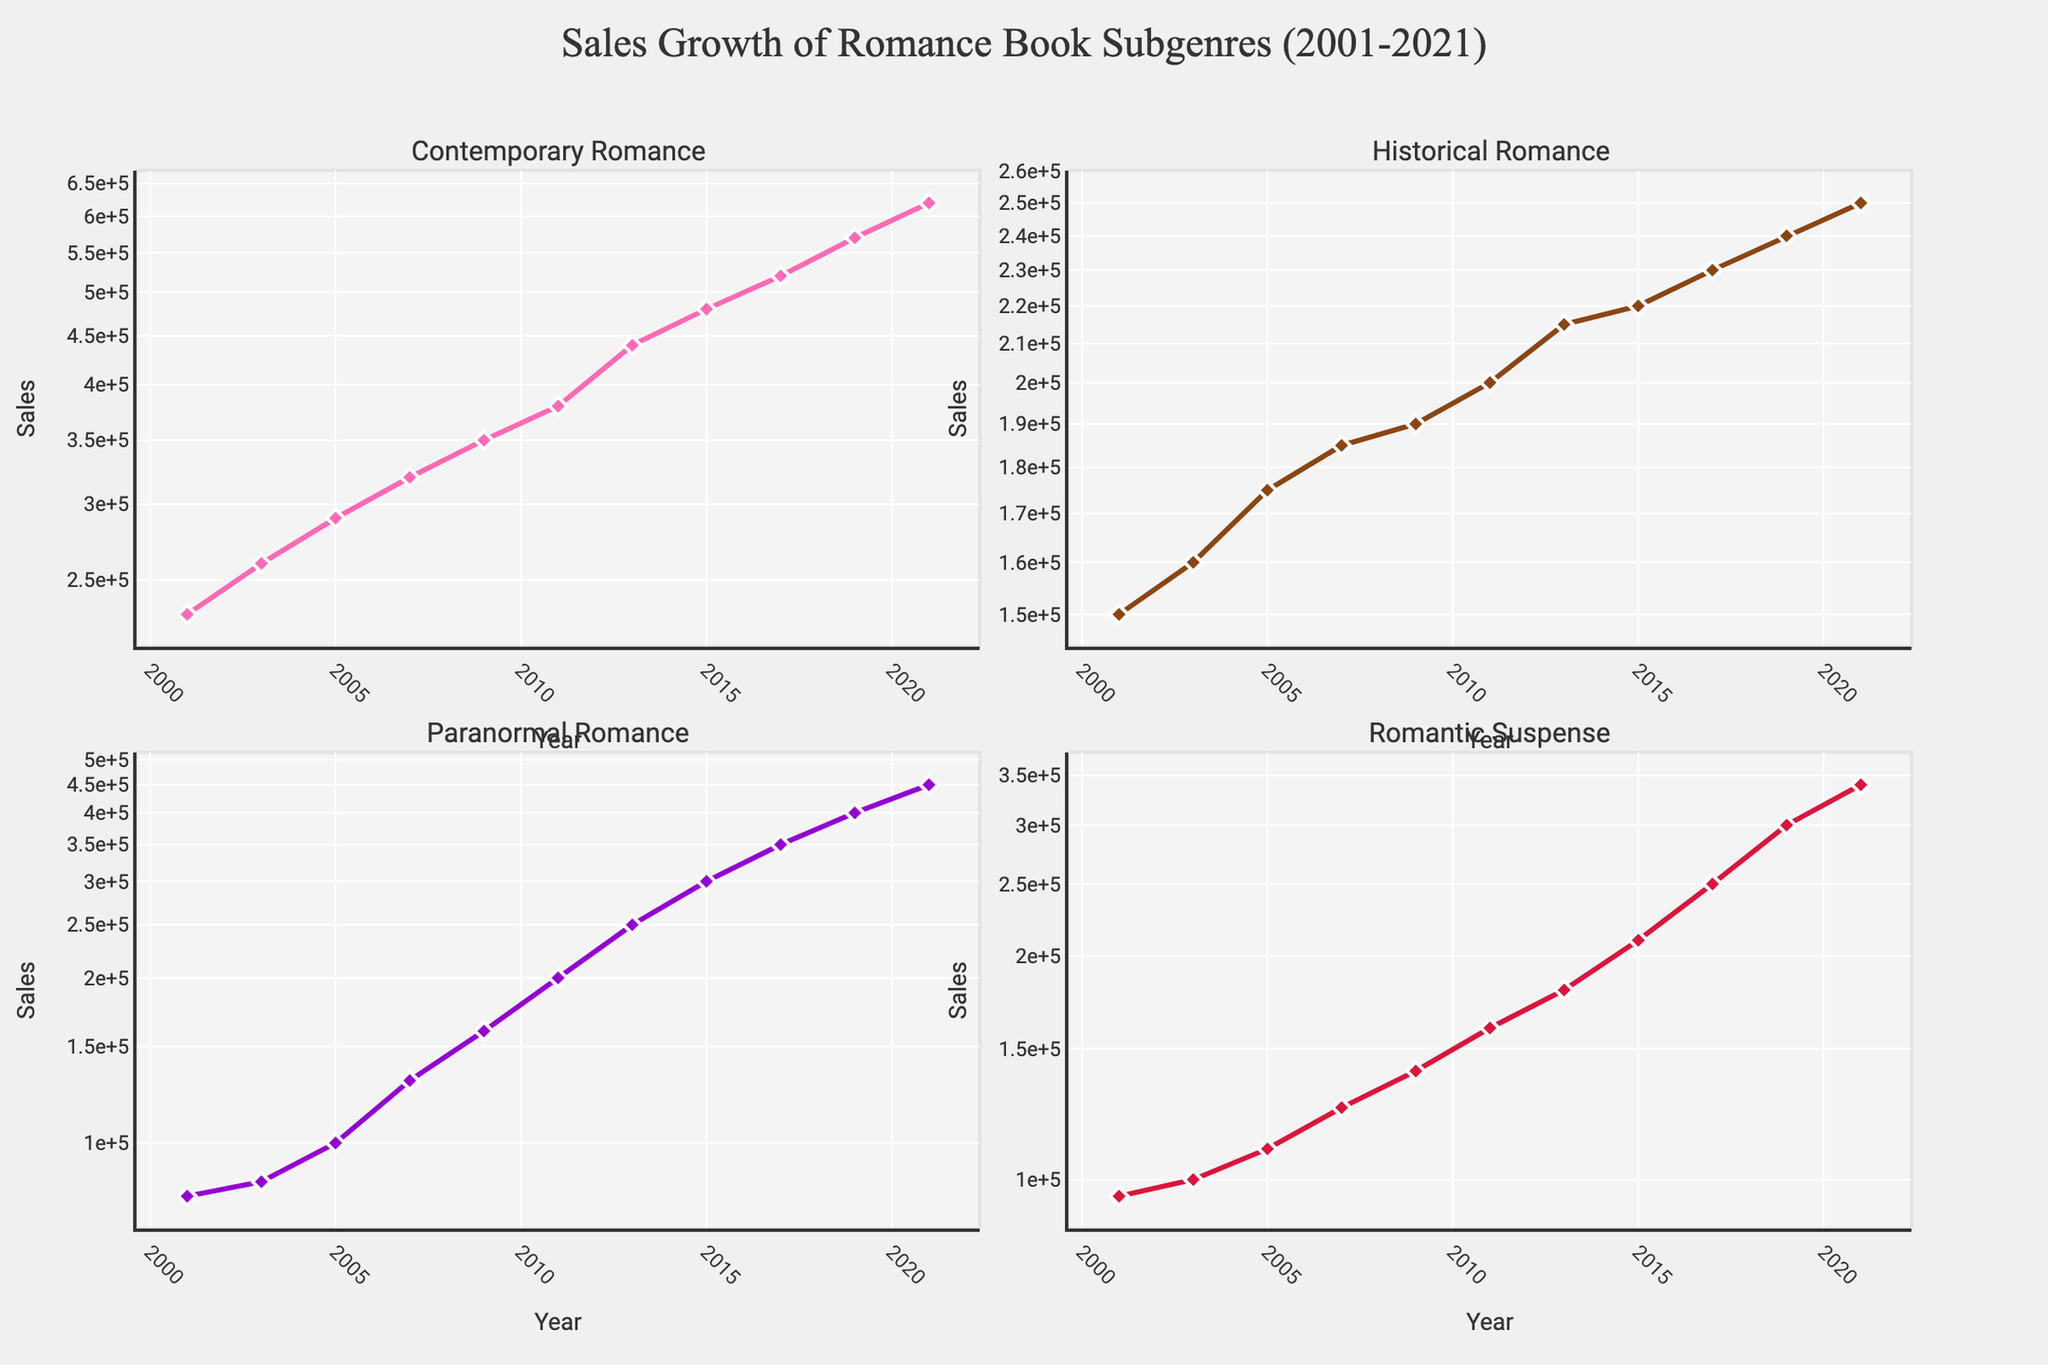What is the title of the plot? The title of the plot is displayed at the top of the figure and it reads "Sales Growth of Romance Book Subgenres (2001-2021)."
Answer: Sales Growth of Romance Book Subgenres (2001-2021) How many subgenres are represented in the figure? The figure has four subplots, each titled with a different subgenre of romance books.
Answer: Four Which subgenre had the highest sales in 2021? Looking at the sales values for 2021 in the subplots, the highest value is found in the "Contemporary Romance" subplot.
Answer: Contemporary Romance In 2009, which subgenre had higher sales, "Historical Romance" or "Paranormal Romance"? In the subplots for 2009, the sales of "Historical Romance" were 190,000 and "Paranormal Romance" were 160,000.
Answer: Historical Romance What trend can be observed for the "Paranormal Romance" subgenre over the years? The "Paranormal Romance" subplot shows an increasing trend in sales from 2001 to 2021. The sales started at 80,000 in 2001 and grew to 450,000 in 2021.
Answer: Increasing trend Between which years did "Romantic Suspense" sales see the highest growth? Between 2013 and 2015, the "Romantic Suspense" sales increased from 180,000 to 210,000. The sales increased by 30,000 during this period, which is the highest growth compared to other years.
Answer: 2013 to 2015 What is the total sales for "Historical Romance" in 2015 and 2019 combined? By adding the sales for "Historical Romance" in 2015 (220,000) and 2019 (240,000), the total sales are 460,000.
Answer: 460,000 Which subgenre shows the greatest variability in sales over the years? The "Paranormal Romance" subplot shows the greatest variability, starting from 80,000 in 2001 and reaching 450,000 in 2021, a range of 370,000.
Answer: Paranormal Romance How do the sales trends for "Contemporary Romance" and "Romantic Suspense" compare between 2001 and 2021? Both "Contemporary Romance" and "Romantic Suspense" show increasing trends, though "Contemporary Romance" demonstrates a higher overall increase. "Contemporary Romance" grew from 230,000 to 620,000, whereas "Romantic Suspense" grew from 95,000 to 340,000.
Answer: Increasing, "Contemporary Romance" has a higher increase What is the smallest sales figure for the "Historical Romance" subgenre between 2001 and 2021? The smallest sales figure for "Historical Romance" is observed in 2001 with sales of 150,000.
Answer: 150,000 